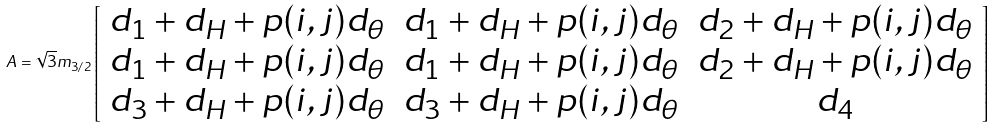<formula> <loc_0><loc_0><loc_500><loc_500>A = \sqrt { 3 } m _ { 3 / 2 } \left [ \begin{array} { c c c } d _ { 1 } + d _ { H } + p ( i , j ) d _ { \theta } & d _ { 1 } + d _ { H } + p ( i , j ) d _ { \theta } & d _ { 2 } + d _ { H } + p ( i , j ) d _ { \theta } \\ d _ { 1 } + d _ { H } + p ( i , j ) d _ { \theta } & d _ { 1 } + d _ { H } + p ( i , j ) d _ { \theta } & d _ { 2 } + d _ { H } + p ( i , j ) d _ { \theta } \\ d _ { 3 } + d _ { H } + p ( i , j ) d _ { \theta } & d _ { 3 } + d _ { H } + p ( i , j ) d _ { \theta } & d _ { 4 } \end{array} \right ]</formula> 